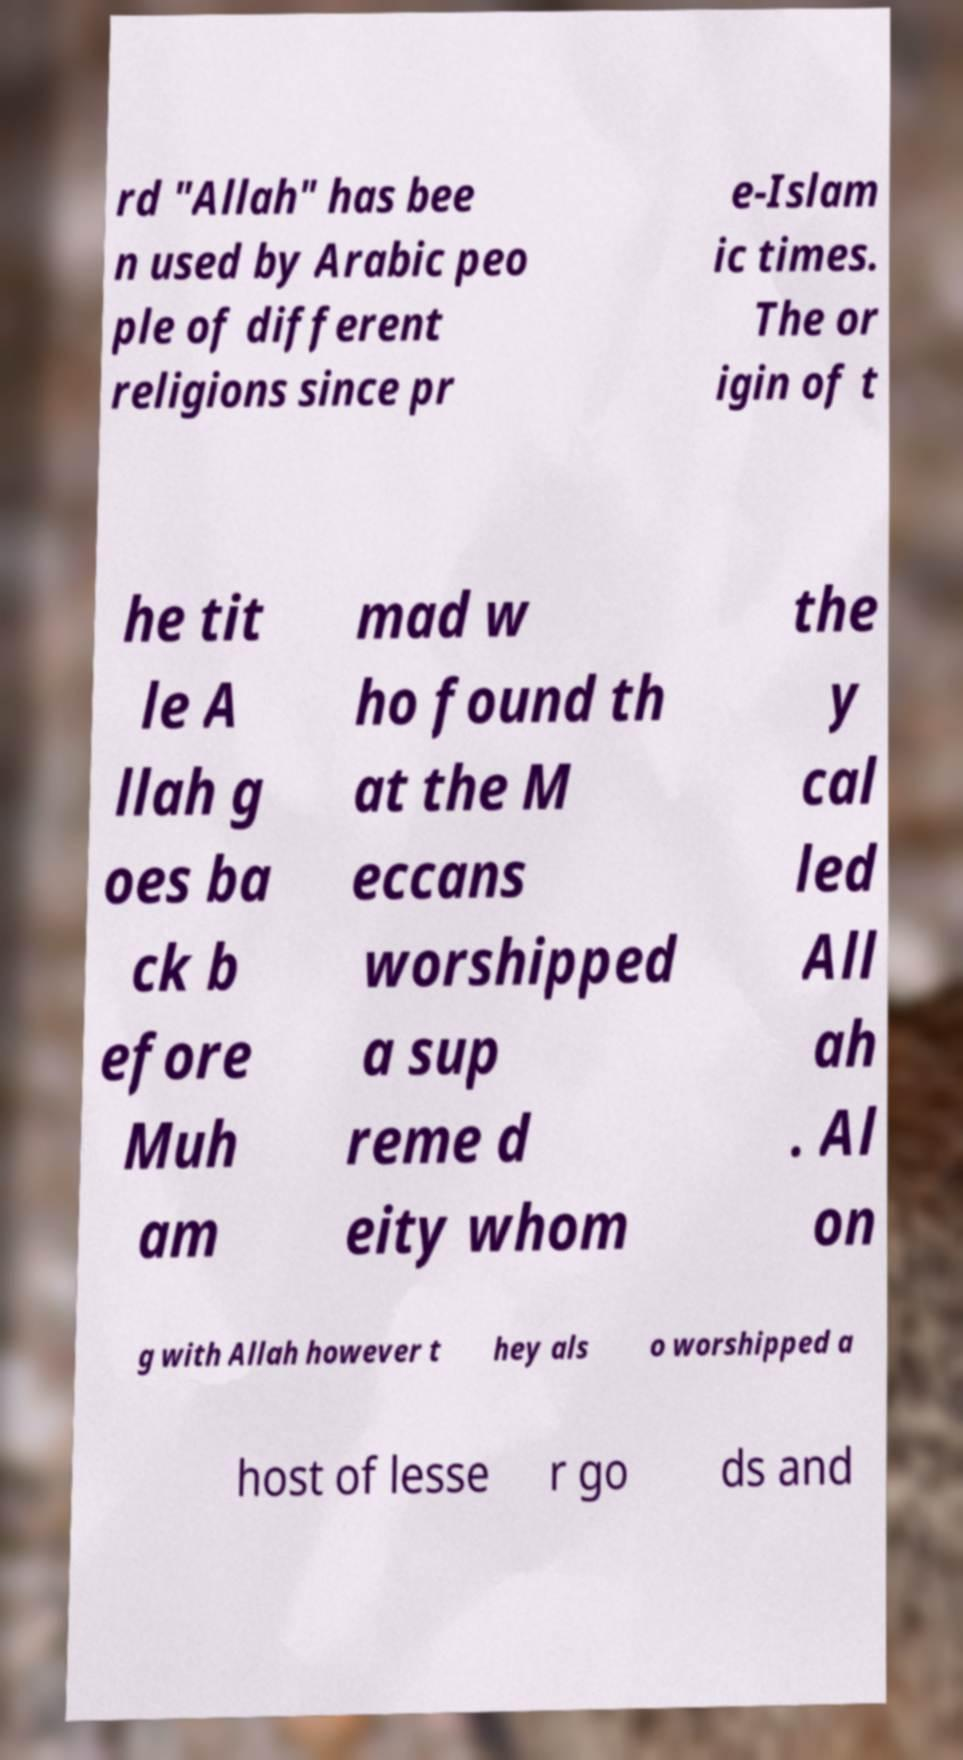Could you extract and type out the text from this image? rd "Allah" has bee n used by Arabic peo ple of different religions since pr e-Islam ic times. The or igin of t he tit le A llah g oes ba ck b efore Muh am mad w ho found th at the M eccans worshipped a sup reme d eity whom the y cal led All ah . Al on g with Allah however t hey als o worshipped a host of lesse r go ds and 